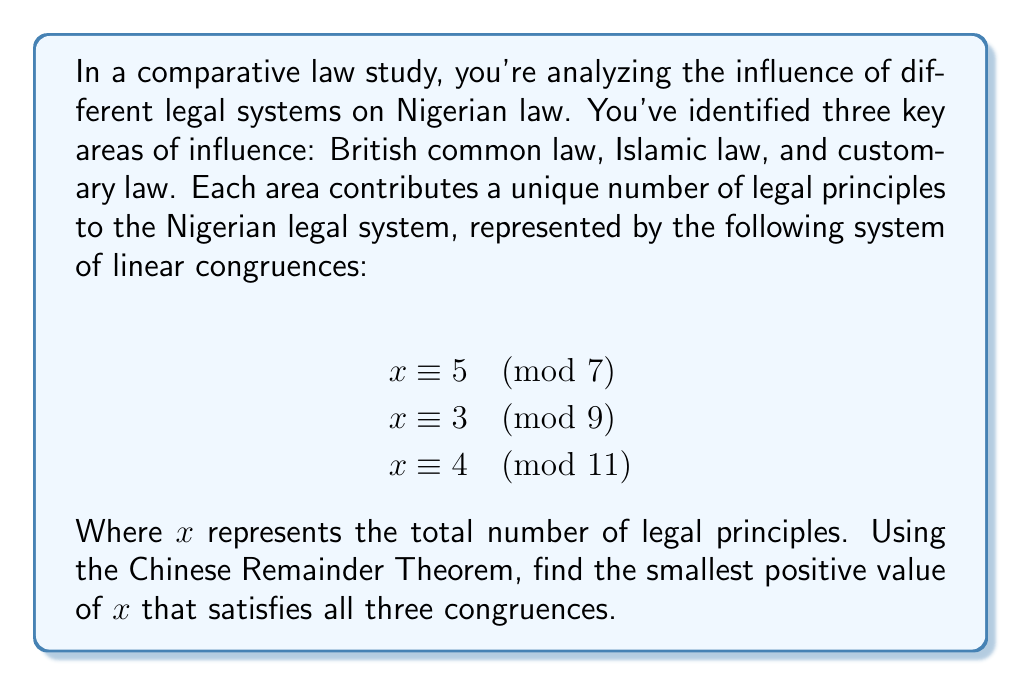What is the answer to this math problem? Let's solve this using the Chinese Remainder Theorem (CRT):

1) First, calculate $M = m_1 \cdot m_2 \cdot m_3 = 7 \cdot 9 \cdot 11 = 693$

2) Calculate $M_i = M / m_i$:
   $M_1 = 693 / 7 = 99$
   $M_2 = 693 / 9 = 77$
   $M_3 = 693 / 11 = 63$

3) Find the modular multiplicative inverses of each $M_i$ modulo $m_i$:
   $99y_1 \equiv 1 \pmod{7} \implies y_1 = 4$
   $77y_2 \equiv 1 \pmod{9} \implies y_2 = 5$
   $63y_3 \equiv 1 \pmod{11} \implies y_3 = 8$

4) Calculate $x$ using the formula:
   $x = (a_1M_1y_1 + a_2M_2y_2 + a_3M_3y_3) \bmod M$
   
   $x = (5 \cdot 99 \cdot 4 + 3 \cdot 77 \cdot 5 + 4 \cdot 63 \cdot 8) \bmod 693$
   
   $x = (1980 + 1155 + 2016) \bmod 693$
   
   $x = 5151 \bmod 693 = 94$

Therefore, the smallest positive value of $x$ that satisfies all three congruences is 94.
Answer: 94 